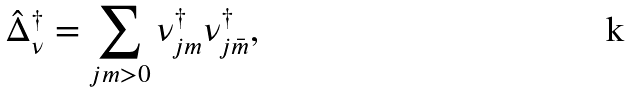<formula> <loc_0><loc_0><loc_500><loc_500>\hat { \Delta } ^ { \dagger } _ { \nu } = \sum _ { j m > 0 } \nu _ { j m } ^ { \dagger } \nu _ { j \bar { m } } ^ { \dagger } ,</formula> 